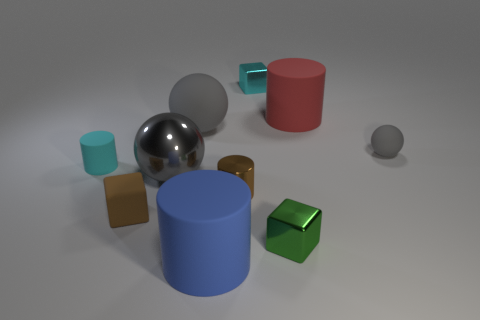Subtract all red blocks. Subtract all cyan cylinders. How many blocks are left? 3 Subtract all cylinders. How many objects are left? 6 Subtract 0 brown spheres. How many objects are left? 10 Subtract all matte things. Subtract all small yellow spheres. How many objects are left? 4 Add 6 red matte things. How many red matte things are left? 7 Add 1 big matte cylinders. How many big matte cylinders exist? 3 